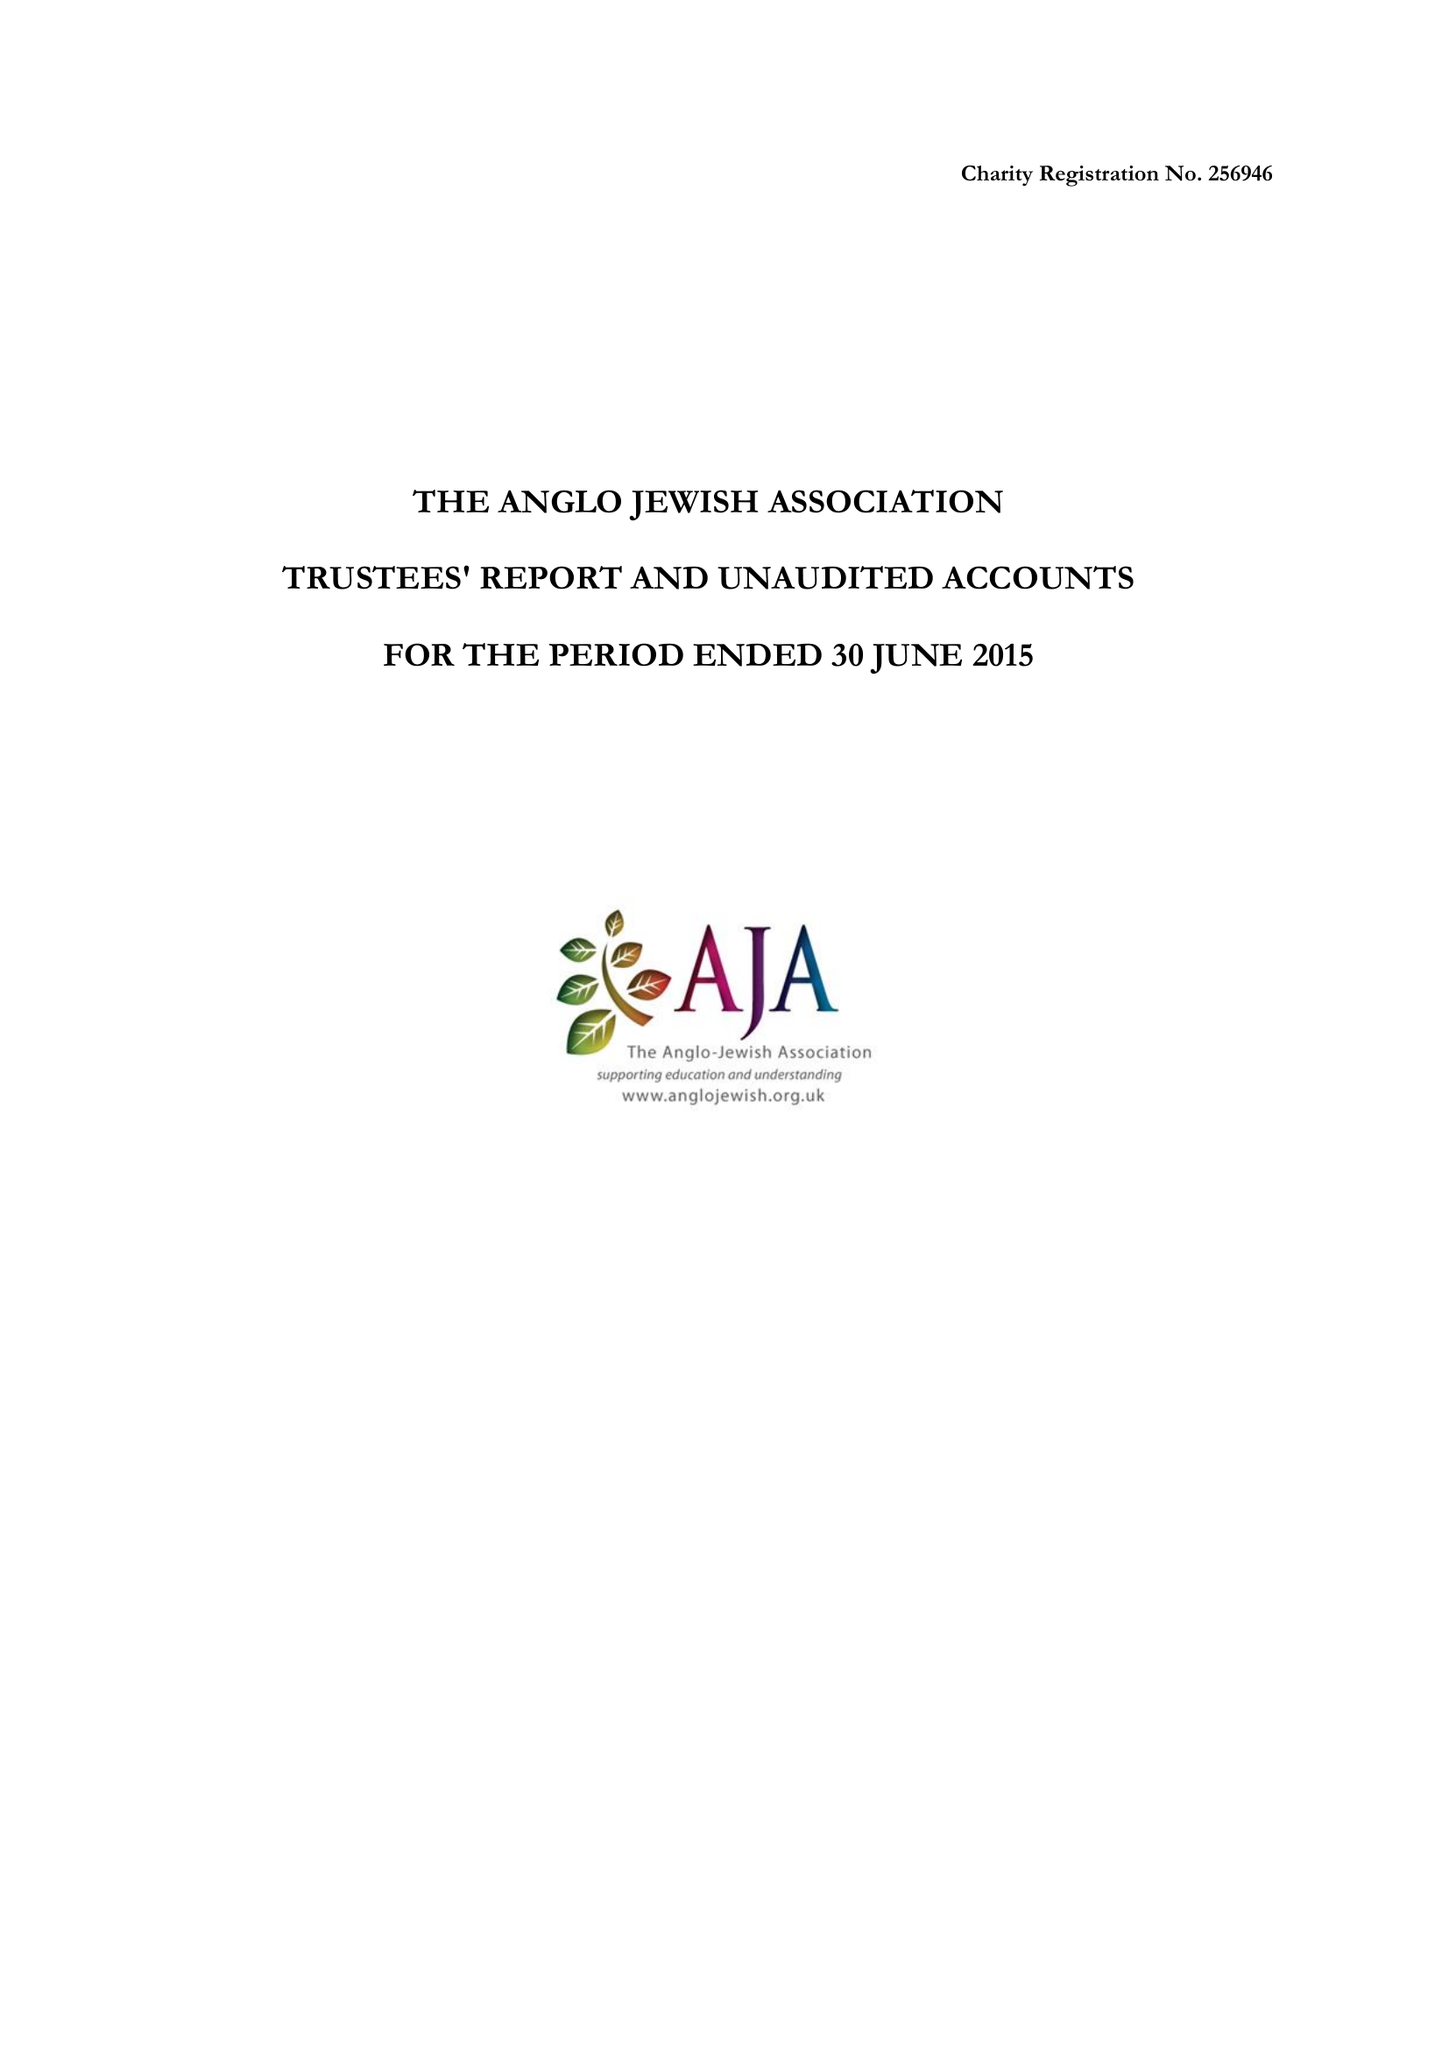What is the value for the address__street_line?
Answer the question using a single word or phrase. 75 MAYGROVE ROAD 